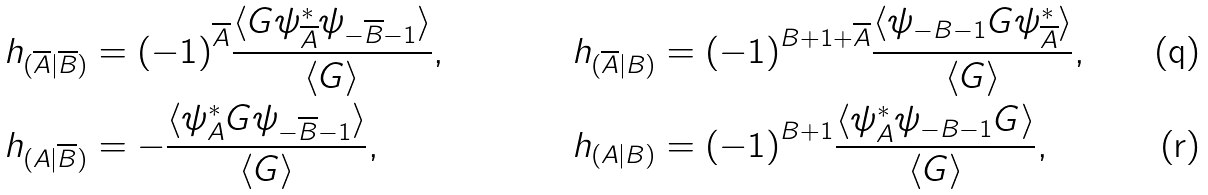Convert formula to latex. <formula><loc_0><loc_0><loc_500><loc_500>\ h _ { ( \overline { A } | \overline { B } ) } & = { ( - 1 ) } ^ { \overline { A } } \frac { \langle G \psi ^ { * } _ { \overline { A } } \psi _ { - \overline { B } - 1 } \rangle } { \langle G \rangle } , & \ h _ { ( \overline { A } | { B } ) } & = { ( - 1 ) } ^ { B + 1 + \overline { A } } \frac { \langle \psi _ { - B - 1 } G \psi ^ { * } _ { \overline { A } } \rangle } { \langle G \rangle } , \\ \ h _ { ( { A } | \overline { B } ) } & = - \frac { \langle \psi ^ { * } _ { A } G \psi _ { - \overline { B } - 1 } \rangle } { \langle G \rangle } , & \ h _ { ( { A } | { B } ) } & = { ( - 1 ) } ^ { B + 1 } \frac { \langle \psi ^ { * } _ { A } \psi _ { - B - 1 } G \rangle } { \langle G \rangle } ,</formula> 